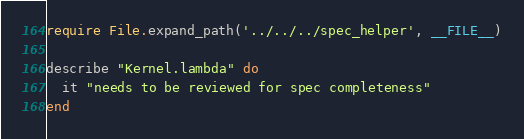<code> <loc_0><loc_0><loc_500><loc_500><_Ruby_>require File.expand_path('../../../spec_helper', __FILE__)

describe "Kernel.lambda" do
  it "needs to be reviewed for spec completeness"
end
</code> 